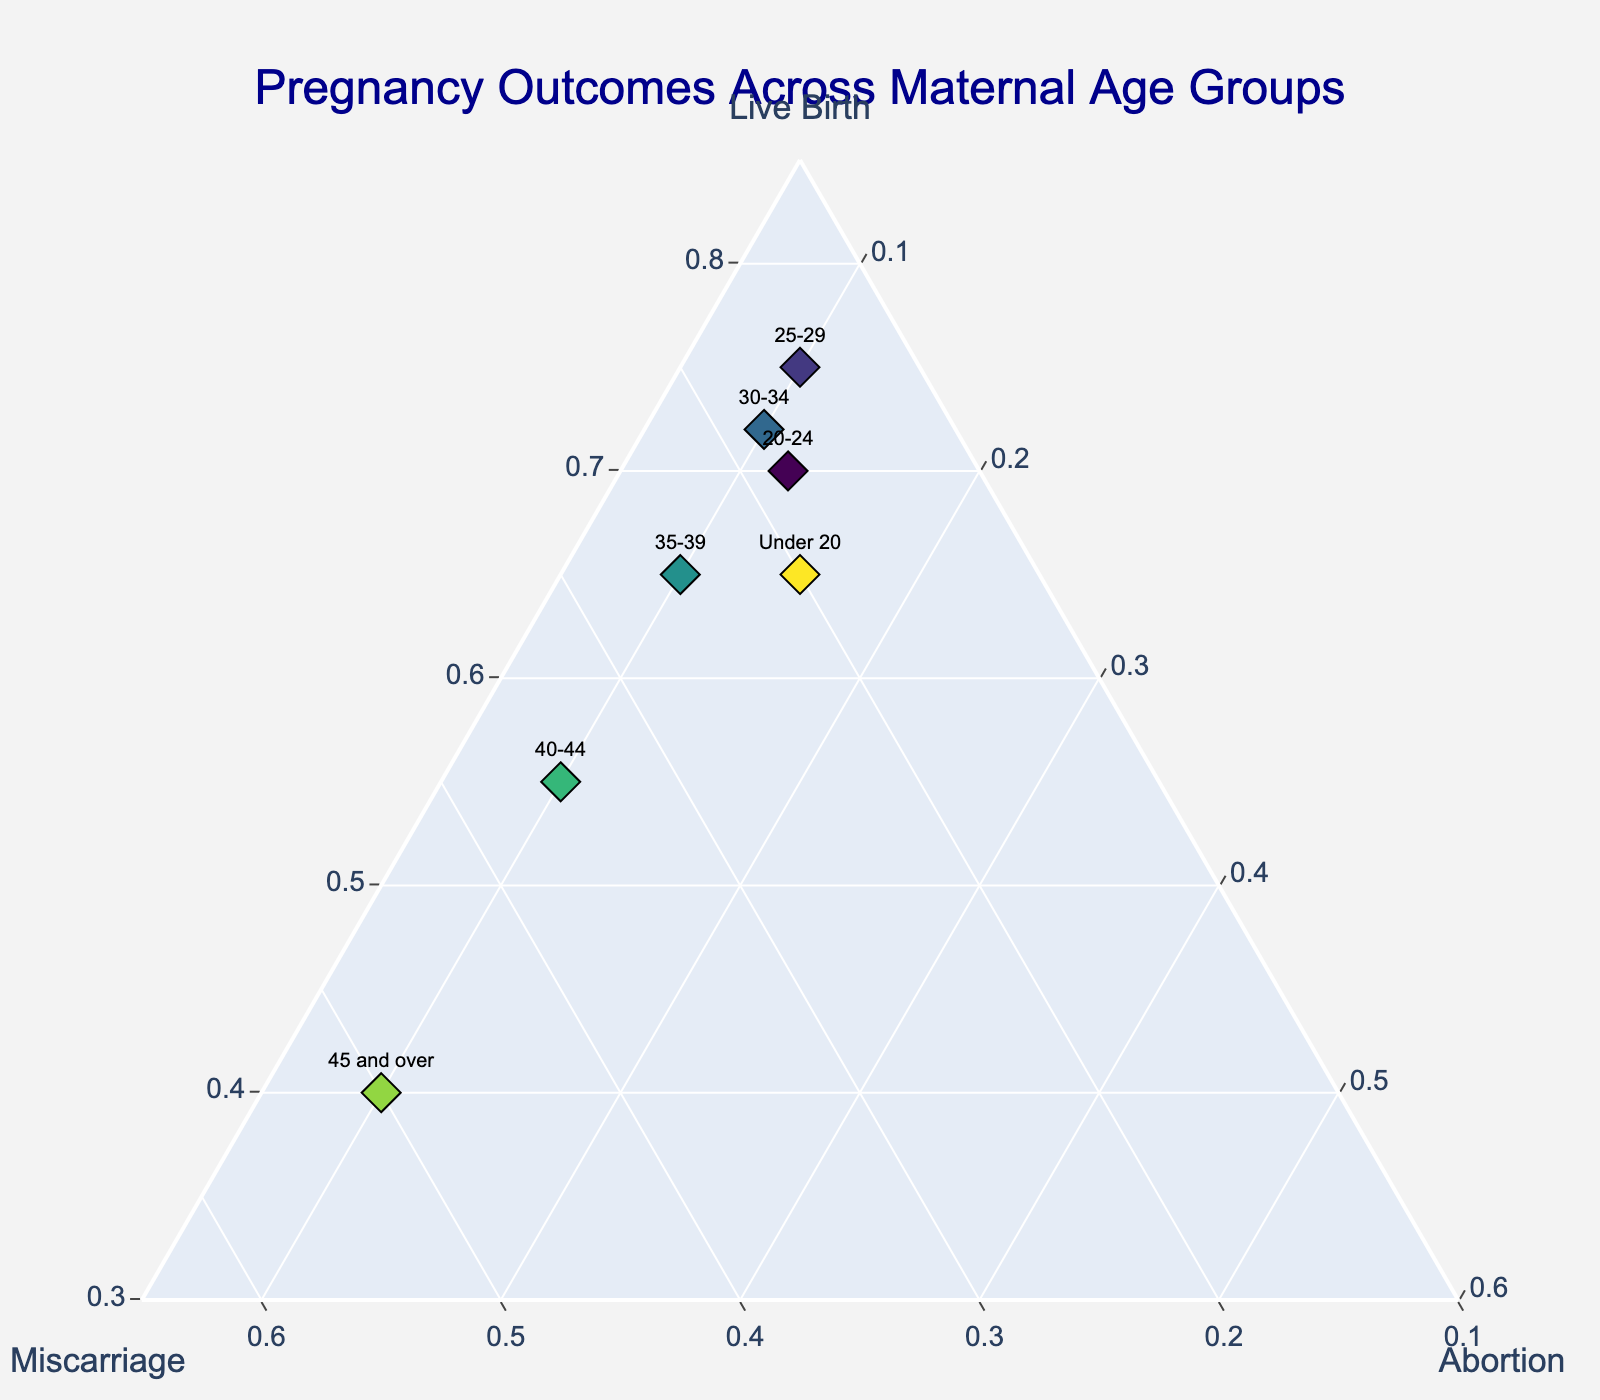What is the title of the figure? The title is text displayed at the top of the plot. It's often used to describe the main topic or focus of the graph.
Answer: Pregnancy Outcomes Across Maternal Age Groups How many data points are shown in the figure? Count the number of different markers on the plot, which correspond to the different age groups represented. There are 7 age groups (Under 20, 20-24, 25-29, 30-34, 35-39, 40-44, 45 and over).
Answer: 7 Which age group has the highest percentage of live births? This asks to find the marker closest to the "Live Birth" axis in the ternary plot. The one closest to the "Live Birth" axis will have the highest proportion of live births. The age group "25-29" appears closest to the Live Birth axis.
Answer: 25-29 How does the proportion of miscarriages compare between the '40-44' and '45 and over' age groups? Compare the positions of these two age groups with respect to the "Miscarriage" axis. '45 and over' is closer to the "Miscarriage" axis indicating a higher proportion of miscarriages compared to '40-44'.
Answer: Higher in '45 and over' Which age group has the smallest proportion of abortions? This requires identifying the point closest to the "Abortion" axis. The closest one indicates the lowest proportion of abortions.
Answer: Under 20 What is the proportion of live births in the '30-34' age group? Locate the '30-34' marker on the ternary plot and look at how far it is from the "Live Birth" axis. The data suggests '30-34' has a 72% live birth rate.
Answer: 72% Compare the proportion of live births between the 'Under 20' and '20-24' age groups. Locate both markers and compare their positions concerning the "Live Birth" axis. '20-24' is slightly closer to the "Live Birth" axis than 'Under 20', indicating a higher proportion.
Answer: Higher in '20-24' What trend do you observe in the proportion of miscarriages as maternal age increases? This requires observing the positions of different age groups concerning the "Miscarriage" axis as maternal age increases. There's an increasing trend in the proportion of miscarriages with maternal age.
Answer: Increasing trend Which age group has the highest proportion of abortions and what is the percentage? Locate the point closest to the "Abortion" axis. The 'Under 20' age group has the highest with the data showing 15%.
Answer: Under 20, 15% 